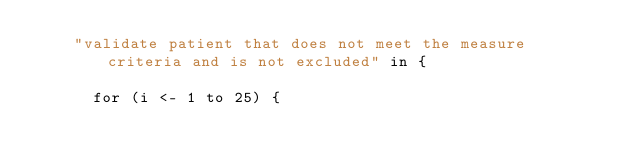<code> <loc_0><loc_0><loc_500><loc_500><_Scala_>    "validate patient that does not meet the measure criteria and is not excluded" in {

      for (i <- 1 to 25) {</code> 